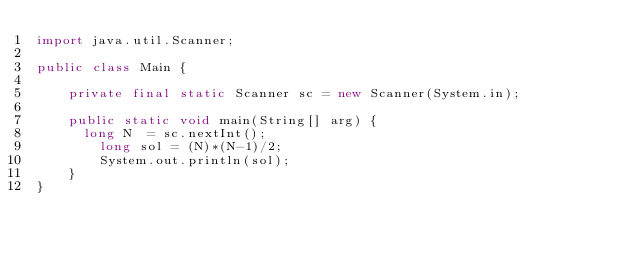Convert code to text. <code><loc_0><loc_0><loc_500><loc_500><_Java_>import java.util.Scanner;
     
public class Main {
    	
    private final static Scanner sc = new Scanner(System.in);
    	
    public static void main(String[] arg) {
    	long N  = sc.nextInt();
        long sol = (N)*(N-1)/2;
      	System.out.println(sol);
   	}
}</code> 